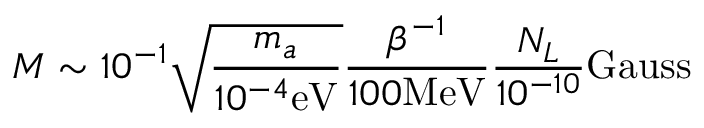Convert formula to latex. <formula><loc_0><loc_0><loc_500><loc_500>M \sim 1 0 ^ { - 1 } \sqrt { \frac { m _ { a } } { 1 0 ^ { - 4 } e V } } \frac { \beta ^ { - 1 } } { 1 0 0 M e V } \frac { N _ { L } } { 1 0 ^ { - 1 0 } } G a u s s</formula> 